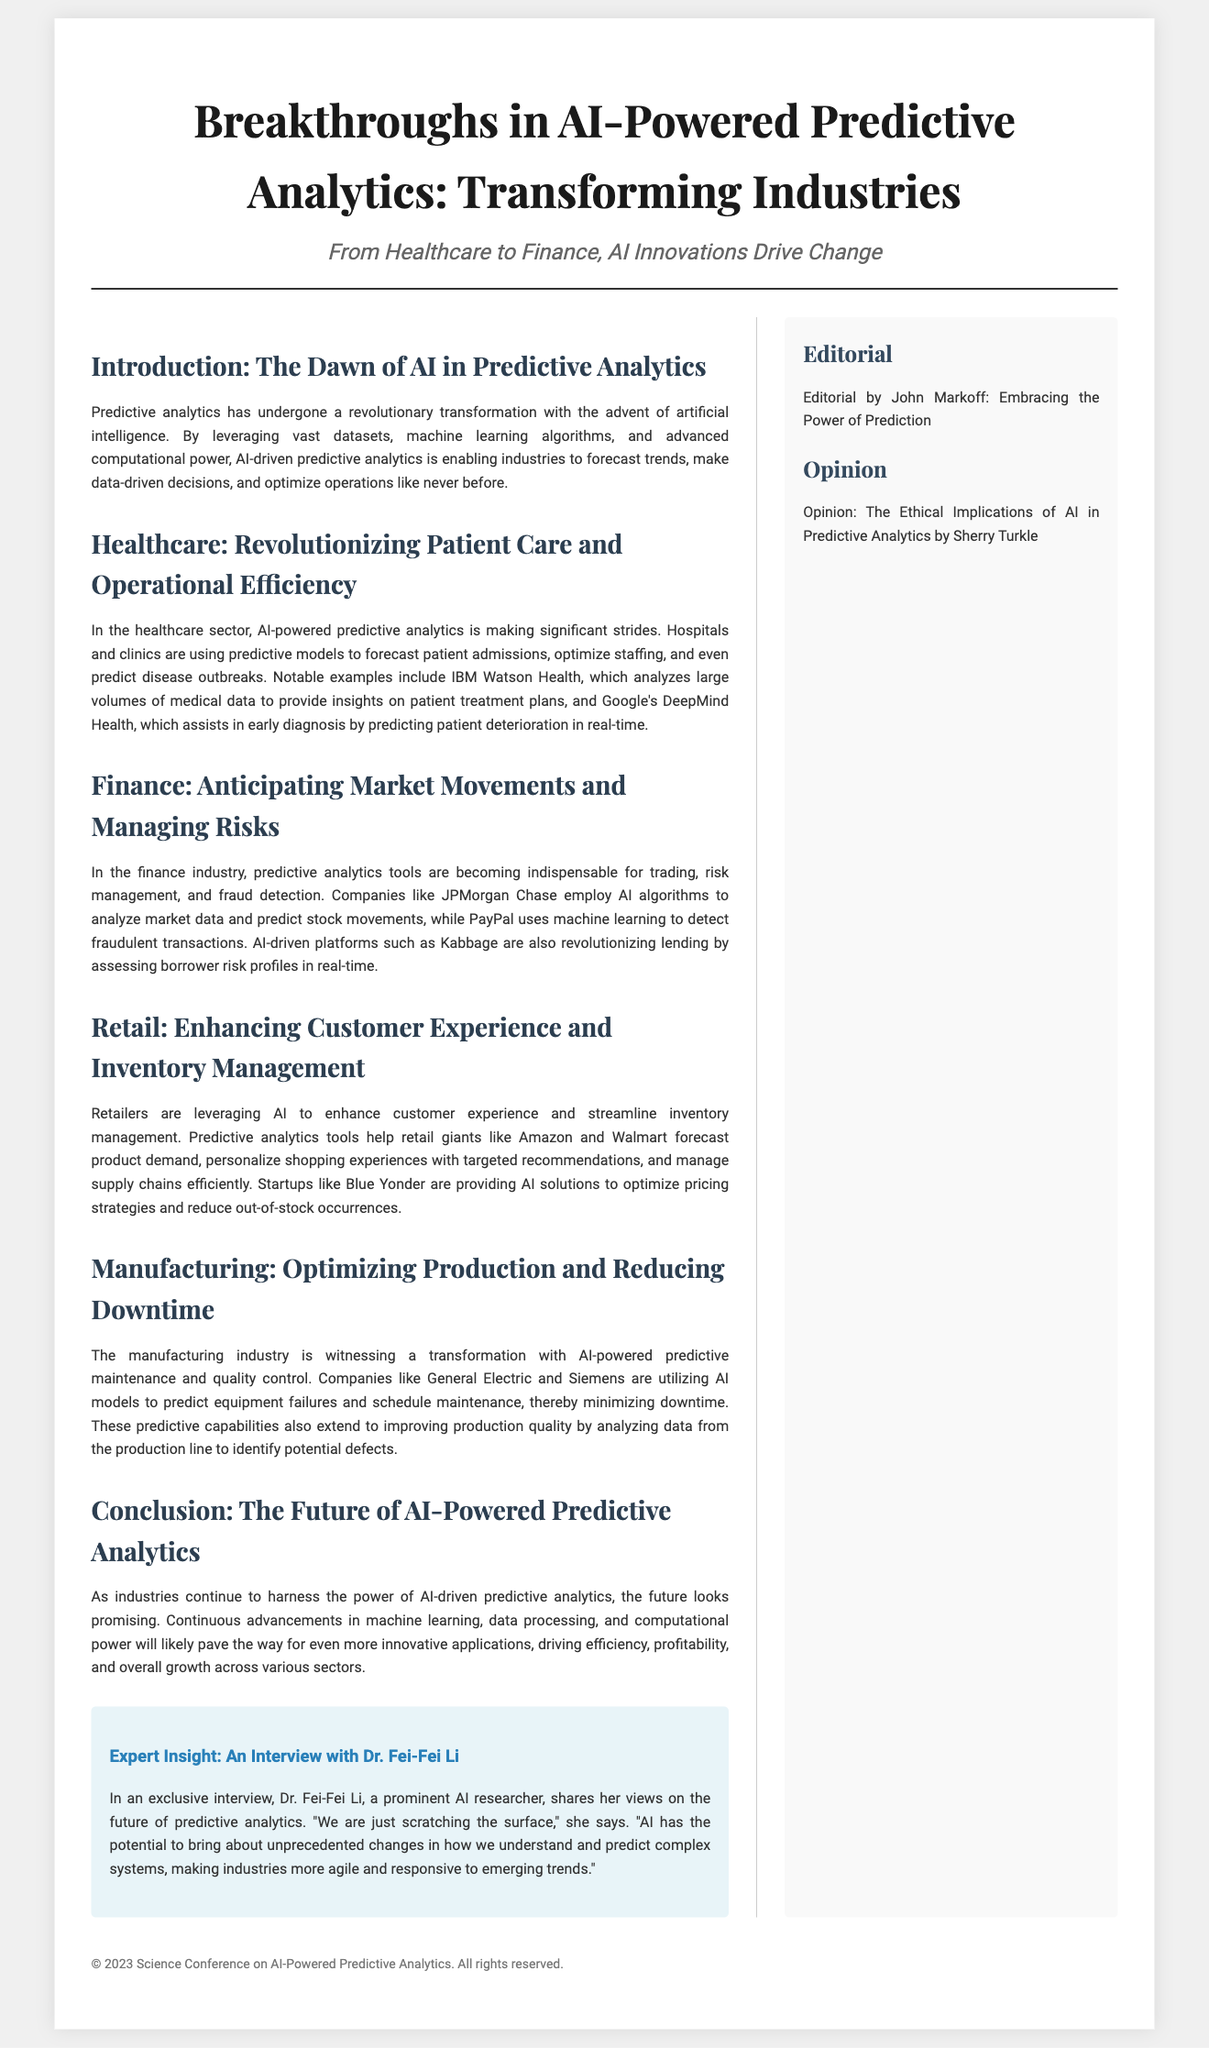What is the main focus of the document? The main focus of the document is detailed in the title, which highlights the advancements in predictive analytics powered by artificial intelligence across various industries.
Answer: AI-Powered Predictive Analytics Who is the expert interviewed in the document? The document includes an interview with a prominent AI researcher who expresses views on predictive analytics.
Answer: Dr. Fei-Fei Li Which industry uses AI for predicting patient deterioration? The document mentions a specific AI project that helps in early diagnoses by predicting patient issues.
Answer: Google’s DeepMind Health What two companies use AI for market predictions in finance? The companies listed that employ AI algorithms for analyzing market data are mentioned in the finance section.
Answer: JPMorgan Chase and PayPal What is the purpose of predictive analytics in manufacturing? The document outlines the specific uses of AI in manufacturing to improve efficiency and quality, which can be inferred as the purpose.
Answer: Optimizing Production and Reducing Downtime What insight does Dr. Fei-Fei Li provide regarding AI's future? The expert provides her expectation about the impact of AI on industries and predictions in complex systems.
Answer: Unprecedented changes What example is given for AI in retail operations? The document lists a specific application of AI in retail regarding inventory management and customer experience.
Answer: Amazon and Walmart What year does the copyright of the document state? The footer mentions a specific year reflecting the copyright notice of the document.
Answer: 2023 